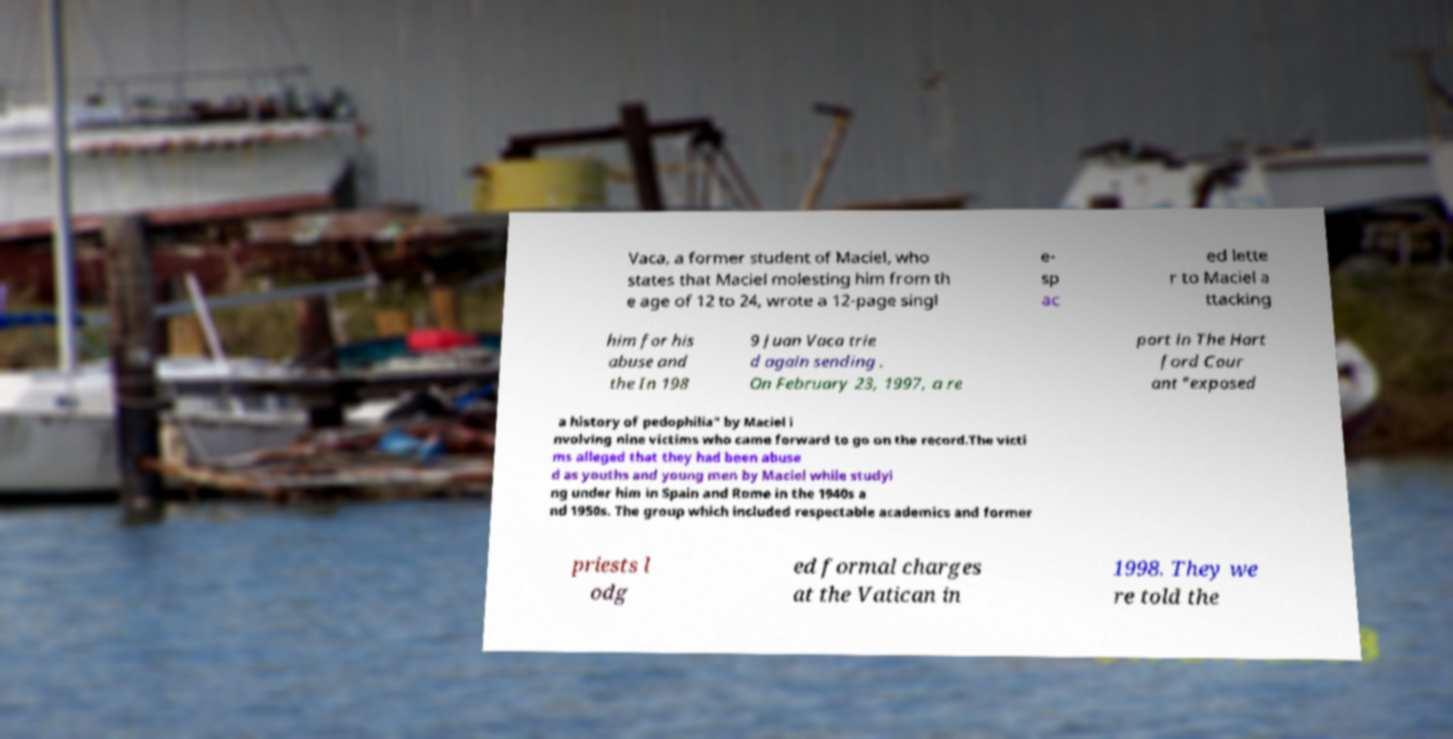Please identify and transcribe the text found in this image. Vaca, a former student of Maciel, who states that Maciel molesting him from th e age of 12 to 24, wrote a 12-page singl e- sp ac ed lette r to Maciel a ttacking him for his abuse and the In 198 9 Juan Vaca trie d again sending . On February 23, 1997, a re port in The Hart ford Cour ant "exposed a history of pedophilia" by Maciel i nvolving nine victims who came forward to go on the record.The victi ms alleged that they had been abuse d as youths and young men by Maciel while studyi ng under him in Spain and Rome in the 1940s a nd 1950s. The group which included respectable academics and former priests l odg ed formal charges at the Vatican in 1998. They we re told the 